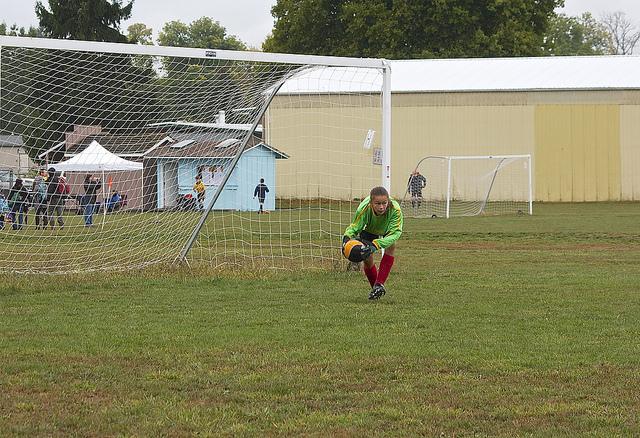What sport is being played?
Give a very brief answer. Soccer. What is the boy doing with ball?
Give a very brief answer. Catching. What color is the soccer ball?
Write a very short answer. Orange. 